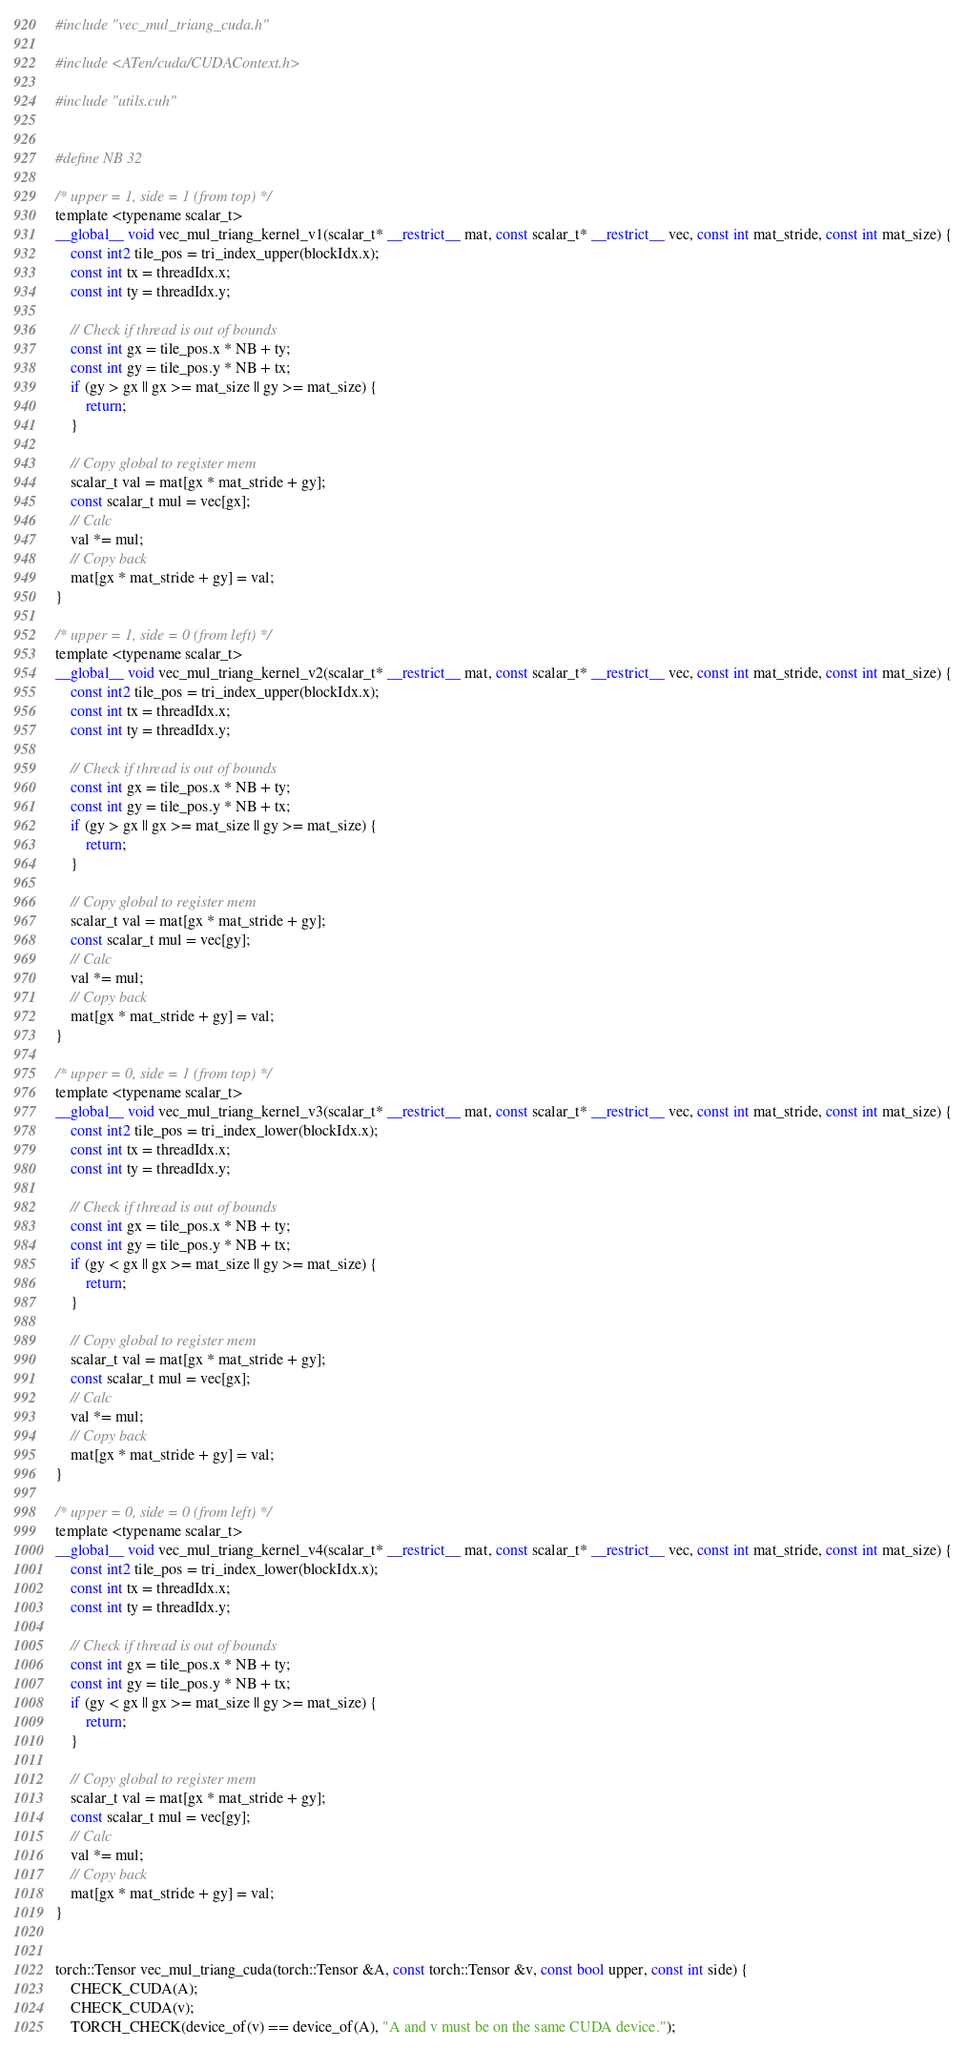<code> <loc_0><loc_0><loc_500><loc_500><_Cuda_>#include "vec_mul_triang_cuda.h"

#include <ATen/cuda/CUDAContext.h>

#include "utils.cuh"


#define NB 32

/* upper = 1, side = 1 (from top) */
template <typename scalar_t>
__global__ void vec_mul_triang_kernel_v1(scalar_t* __restrict__ mat, const scalar_t* __restrict__ vec, const int mat_stride, const int mat_size) {
    const int2 tile_pos = tri_index_upper(blockIdx.x);
    const int tx = threadIdx.x;
    const int ty = threadIdx.y;

    // Check if thread is out of bounds
    const int gx = tile_pos.x * NB + ty;
    const int gy = tile_pos.y * NB + tx;
    if (gy > gx || gx >= mat_size || gy >= mat_size) {
        return;
    }

    // Copy global to register mem
    scalar_t val = mat[gx * mat_stride + gy];
    const scalar_t mul = vec[gx];
    // Calc
    val *= mul;
    // Copy back
    mat[gx * mat_stride + gy] = val;
}

/* upper = 1, side = 0 (from left) */
template <typename scalar_t>
__global__ void vec_mul_triang_kernel_v2(scalar_t* __restrict__ mat, const scalar_t* __restrict__ vec, const int mat_stride, const int mat_size) {
    const int2 tile_pos = tri_index_upper(blockIdx.x);
    const int tx = threadIdx.x;
    const int ty = threadIdx.y;

    // Check if thread is out of bounds
    const int gx = tile_pos.x * NB + ty;
    const int gy = tile_pos.y * NB + tx;
    if (gy > gx || gx >= mat_size || gy >= mat_size) {
        return;
    }

    // Copy global to register mem
    scalar_t val = mat[gx * mat_stride + gy];
    const scalar_t mul = vec[gy];
    // Calc
    val *= mul;
    // Copy back
    mat[gx * mat_stride + gy] = val;
}

/* upper = 0, side = 1 (from top) */
template <typename scalar_t>
__global__ void vec_mul_triang_kernel_v3(scalar_t* __restrict__ mat, const scalar_t* __restrict__ vec, const int mat_stride, const int mat_size) {
    const int2 tile_pos = tri_index_lower(blockIdx.x);
    const int tx = threadIdx.x;
    const int ty = threadIdx.y;

    // Check if thread is out of bounds
    const int gx = tile_pos.x * NB + ty;
    const int gy = tile_pos.y * NB + tx;
    if (gy < gx || gx >= mat_size || gy >= mat_size) {
        return;
    }

    // Copy global to register mem
    scalar_t val = mat[gx * mat_stride + gy];
    const scalar_t mul = vec[gx];
    // Calc
    val *= mul;
    // Copy back
    mat[gx * mat_stride + gy] = val;
}

/* upper = 0, side = 0 (from left) */
template <typename scalar_t>
__global__ void vec_mul_triang_kernel_v4(scalar_t* __restrict__ mat, const scalar_t* __restrict__ vec, const int mat_stride, const int mat_size) {
    const int2 tile_pos = tri_index_lower(blockIdx.x);
    const int tx = threadIdx.x;
    const int ty = threadIdx.y;

    // Check if thread is out of bounds
    const int gx = tile_pos.x * NB + ty;
    const int gy = tile_pos.y * NB + tx;
    if (gy < gx || gx >= mat_size || gy >= mat_size) {
        return;
    }

    // Copy global to register mem
    scalar_t val = mat[gx * mat_stride + gy];
    const scalar_t mul = vec[gy];
    // Calc
    val *= mul;
    // Copy back
    mat[gx * mat_stride + gy] = val;
}


torch::Tensor vec_mul_triang_cuda(torch::Tensor &A, const torch::Tensor &v, const bool upper, const int side) {
    CHECK_CUDA(A);
    CHECK_CUDA(v);
    TORCH_CHECK(device_of(v) == device_of(A), "A and v must be on the same CUDA device.");</code> 